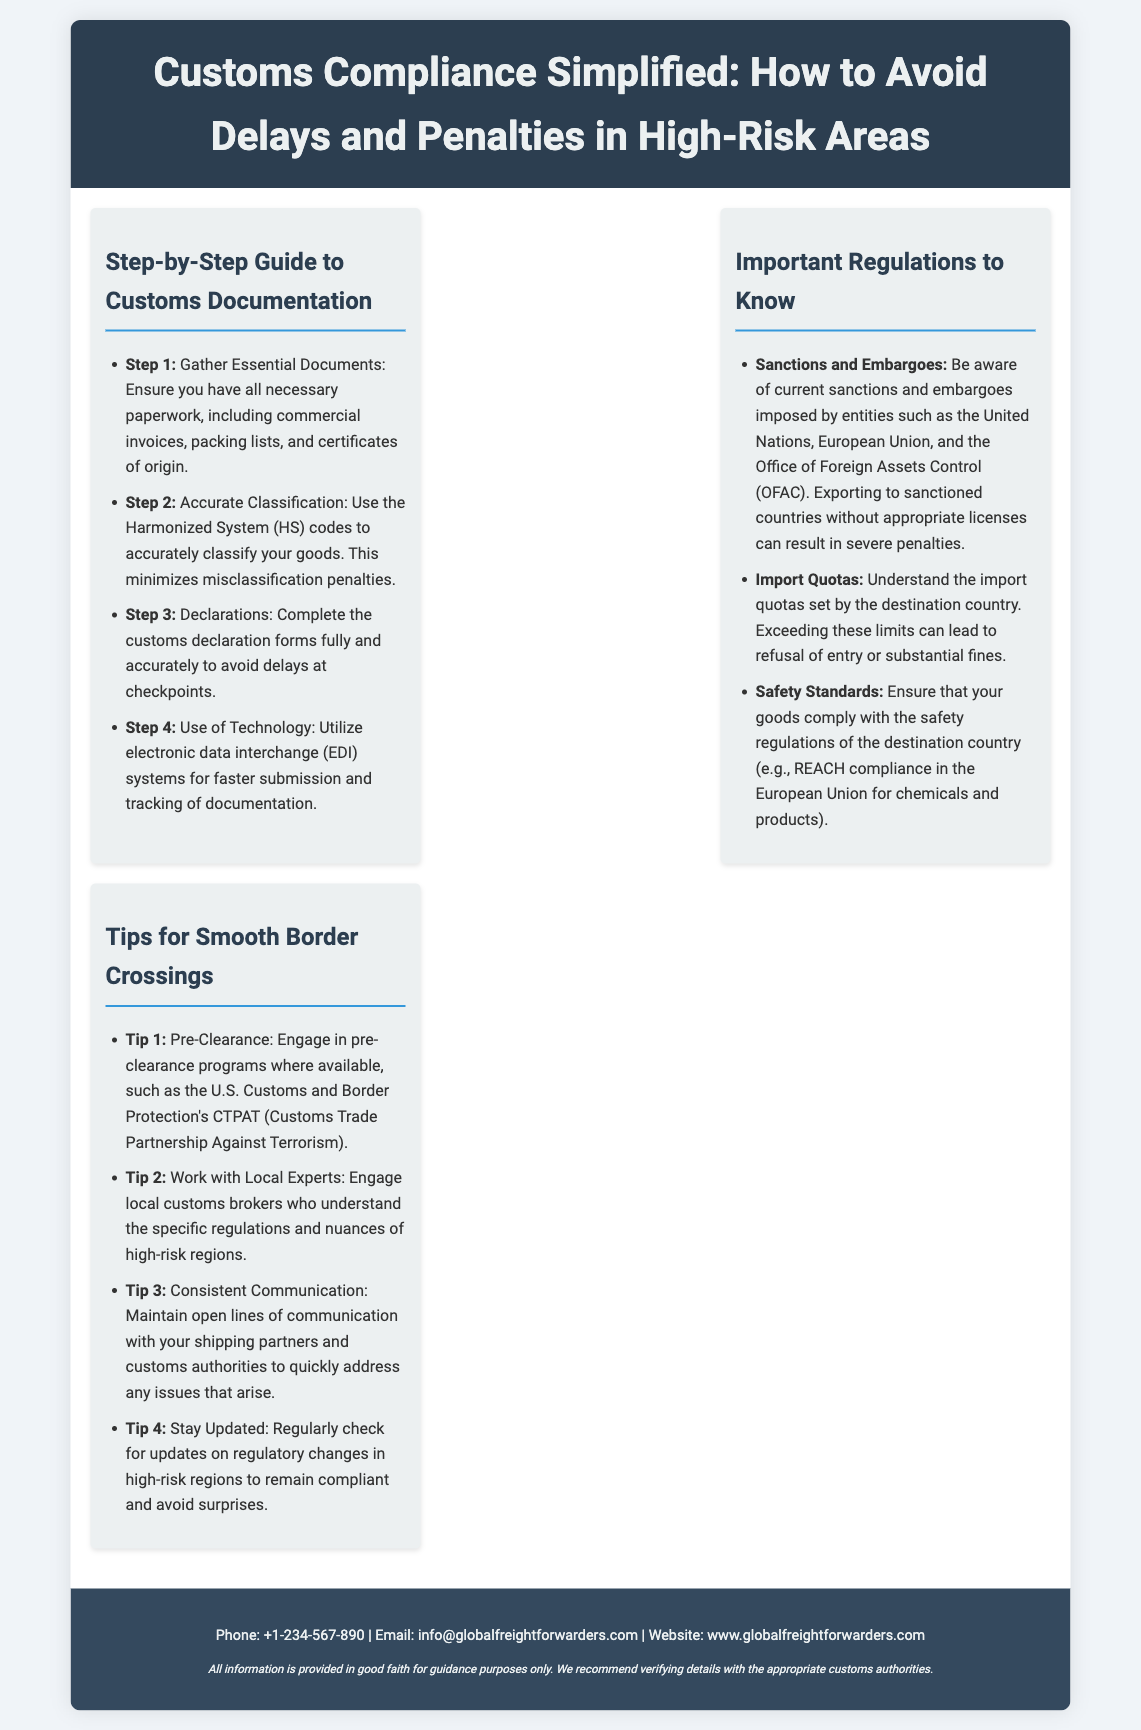what is the title of the flyer? The title of the flyer is displayed prominently at the top, indicating its subject.
Answer: Customs Compliance Simplified: How to Avoid Delays and Penalties in High-Risk Areas how many steps are outlined in the guide to customs documentation? The document lists four distinct steps in the guide to customs documentation.
Answer: 4 what is the first step in the customs documentation guide? The first step is mentioned in the list of steps for customs documentation.
Answer: Gather Essential Documents which organization is responsible for the sanctions and embargoes mentioned? The document lists entities that impose sanctions, specifying one of them in particular.
Answer: United Nations what is a tip for smooth border crossings? The document provides multiple tips; this question asks for one of those mentioned tips.
Answer: Pre-Clearance how many important regulations are listed in the flyer? The flyer outlines three important regulations to know regarding customs compliance.
Answer: 3 what is the recommended action for maintaining communication? The document emphasizes the importance of communication with a specific audience.
Answer: Consistent Communication who should you engage for understanding local regulations? The document suggests a specific type of professional for navigating local regulations in high-risk areas.
Answer: Local customs brokers 